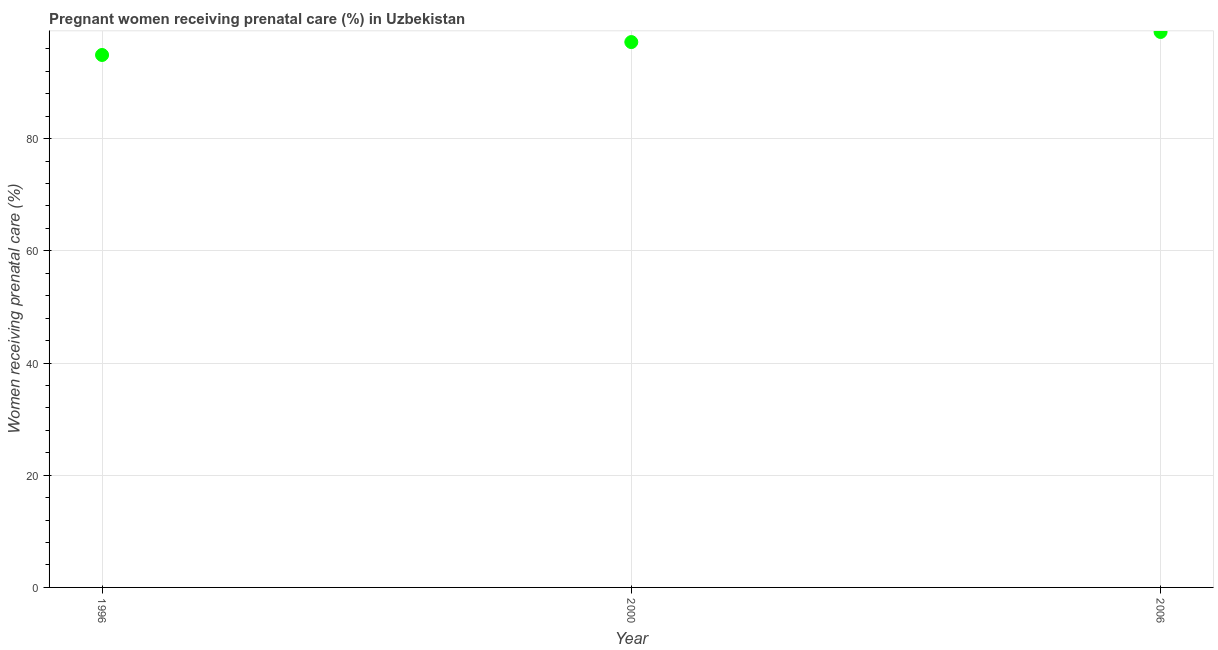Across all years, what is the minimum percentage of pregnant women receiving prenatal care?
Give a very brief answer. 94.9. In which year was the percentage of pregnant women receiving prenatal care maximum?
Your answer should be compact. 2006. What is the sum of the percentage of pregnant women receiving prenatal care?
Your answer should be very brief. 291.1. What is the difference between the percentage of pregnant women receiving prenatal care in 1996 and 2000?
Keep it short and to the point. -2.3. What is the average percentage of pregnant women receiving prenatal care per year?
Provide a succinct answer. 97.03. What is the median percentage of pregnant women receiving prenatal care?
Your response must be concise. 97.2. In how many years, is the percentage of pregnant women receiving prenatal care greater than 56 %?
Provide a short and direct response. 3. Do a majority of the years between 2000 and 1996 (inclusive) have percentage of pregnant women receiving prenatal care greater than 80 %?
Your answer should be compact. No. What is the ratio of the percentage of pregnant women receiving prenatal care in 1996 to that in 2006?
Make the answer very short. 0.96. Is the percentage of pregnant women receiving prenatal care in 1996 less than that in 2000?
Your response must be concise. Yes. Is the difference between the percentage of pregnant women receiving prenatal care in 2000 and 2006 greater than the difference between any two years?
Provide a short and direct response. No. What is the difference between the highest and the second highest percentage of pregnant women receiving prenatal care?
Your response must be concise. 1.8. What is the difference between the highest and the lowest percentage of pregnant women receiving prenatal care?
Your answer should be compact. 4.1. How many dotlines are there?
Your answer should be very brief. 1. How many years are there in the graph?
Give a very brief answer. 3. What is the difference between two consecutive major ticks on the Y-axis?
Offer a very short reply. 20. Are the values on the major ticks of Y-axis written in scientific E-notation?
Offer a very short reply. No. Does the graph contain any zero values?
Your answer should be compact. No. Does the graph contain grids?
Give a very brief answer. Yes. What is the title of the graph?
Keep it short and to the point. Pregnant women receiving prenatal care (%) in Uzbekistan. What is the label or title of the Y-axis?
Keep it short and to the point. Women receiving prenatal care (%). What is the Women receiving prenatal care (%) in 1996?
Keep it short and to the point. 94.9. What is the Women receiving prenatal care (%) in 2000?
Offer a very short reply. 97.2. What is the Women receiving prenatal care (%) in 2006?
Provide a succinct answer. 99. What is the difference between the Women receiving prenatal care (%) in 1996 and 2000?
Ensure brevity in your answer.  -2.3. What is the difference between the Women receiving prenatal care (%) in 1996 and 2006?
Offer a terse response. -4.1. What is the difference between the Women receiving prenatal care (%) in 2000 and 2006?
Make the answer very short. -1.8. What is the ratio of the Women receiving prenatal care (%) in 2000 to that in 2006?
Offer a terse response. 0.98. 